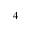<formula> <loc_0><loc_0><loc_500><loc_500>_ { 4 }</formula> 